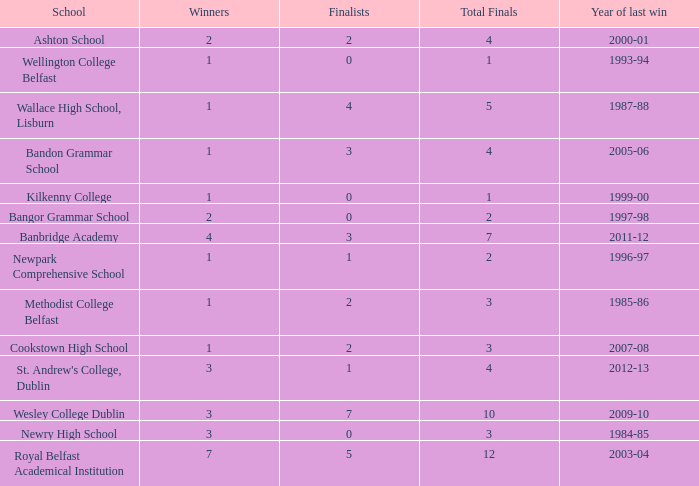How many total finals where there when the last win was in 2012-13? 4.0. 